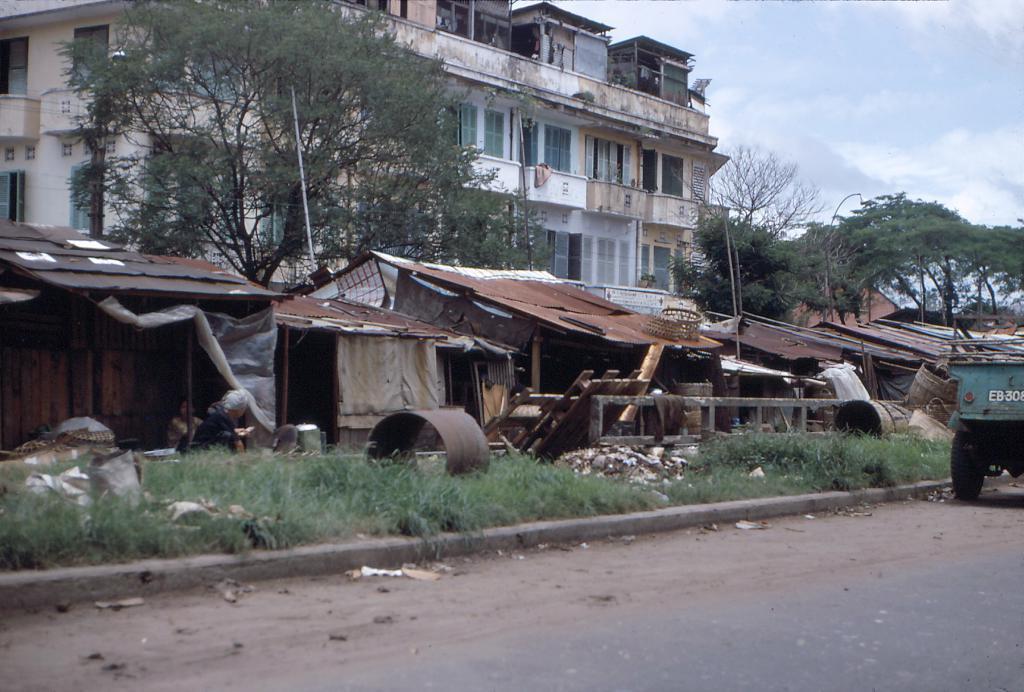Please provide a concise description of this image. In the background there is a sky. On the left side of the picture we can see a building, trees, huts, grass and other objects. This is a road. 